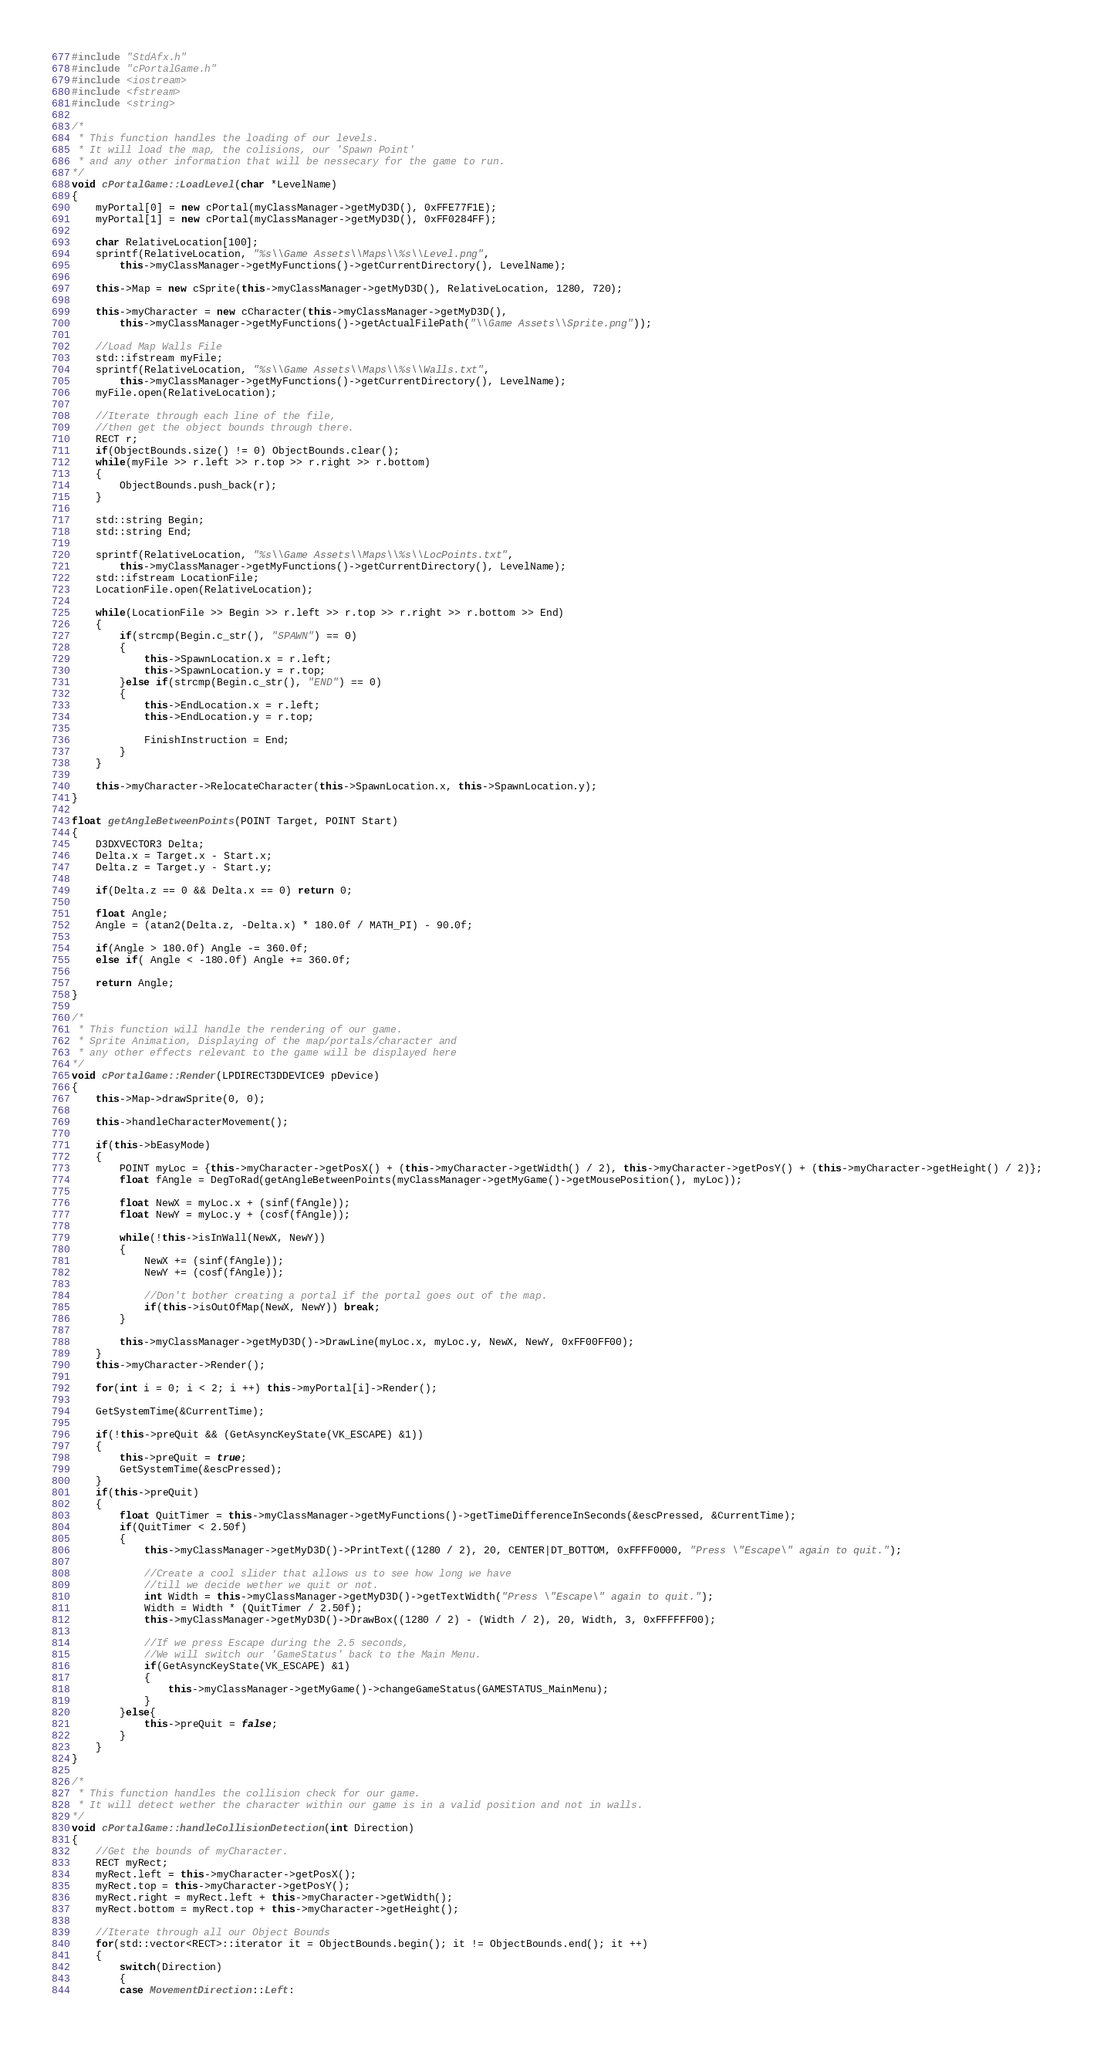<code> <loc_0><loc_0><loc_500><loc_500><_C++_>#include "StdAfx.h"
#include "cPortalGame.h"
#include <iostream>
#include <fstream>
#include <string>

/*
 * This function handles the loading of our levels.
 * It will load the map, the colisions, our 'Spawn Point'
 * and any other information that will be nessecary for the game to run.
*/
void cPortalGame::LoadLevel(char *LevelName)
{
	myPortal[0] = new cPortal(myClassManager->getMyD3D(), 0xFFE77F1E);
	myPortal[1] = new cPortal(myClassManager->getMyD3D(), 0xFF0284FF);

	char RelativeLocation[100];
	sprintf(RelativeLocation, "%s\\Game Assets\\Maps\\%s\\Level.png", 
		this->myClassManager->getMyFunctions()->getCurrentDirectory(), LevelName);

	this->Map = new cSprite(this->myClassManager->getMyD3D(), RelativeLocation, 1280, 720);

	this->myCharacter = new cCharacter(this->myClassManager->getMyD3D(),
		this->myClassManager->getMyFunctions()->getActualFilePath("\\Game Assets\\Sprite.png"));

	//Load Map Walls File
	std::ifstream myFile;
	sprintf(RelativeLocation, "%s\\Game Assets\\Maps\\%s\\Walls.txt", 
		this->myClassManager->getMyFunctions()->getCurrentDirectory(), LevelName);
	myFile.open(RelativeLocation);

	//Iterate through each line of the file,
	//then get the object bounds through there.
	RECT r;
	if(ObjectBounds.size() != 0) ObjectBounds.clear();
	while(myFile >> r.left >> r.top >> r.right >> r.bottom)
	{
		ObjectBounds.push_back(r);
	}

	std::string Begin;
	std::string End;

	sprintf(RelativeLocation, "%s\\Game Assets\\Maps\\%s\\LocPoints.txt", 
		this->myClassManager->getMyFunctions()->getCurrentDirectory(), LevelName);
	std::ifstream LocationFile;
	LocationFile.open(RelativeLocation);

	while(LocationFile >> Begin >> r.left >> r.top >> r.right >> r.bottom >> End)
	{
		if(strcmp(Begin.c_str(), "SPAWN") == 0) 
		{	
			this->SpawnLocation.x = r.left;
			this->SpawnLocation.y = r.top;
		}else if(strcmp(Begin.c_str(), "END") == 0)
		{
			this->EndLocation.x = r.left;
			this->EndLocation.y = r.top;

			FinishInstruction = End;
		}
	}
	
	this->myCharacter->RelocateCharacter(this->SpawnLocation.x, this->SpawnLocation.y);
}

float getAngleBetweenPoints(POINT Target, POINT Start)
{
	D3DXVECTOR3 Delta;
	Delta.x = Target.x - Start.x;
	Delta.z = Target.y - Start.y;

	if(Delta.z == 0 && Delta.x == 0) return 0;

	float Angle;
	Angle = (atan2(Delta.z, -Delta.x) * 180.0f / MATH_PI) - 90.0f;

	if(Angle > 180.0f) Angle -= 360.0f;
	else if( Angle < -180.0f) Angle += 360.0f;

	return Angle;
}

/*
 * This function will handle the rendering of our game.
 * Sprite Animation, Displaying of the map/portals/character and
 * any other effects relevant to the game will be displayed here
*/
void cPortalGame::Render(LPDIRECT3DDEVICE9 pDevice)
{
	this->Map->drawSprite(0, 0);

	this->handleCharacterMovement();

	if(this->bEasyMode)
	{
		POINT myLoc = {this->myCharacter->getPosX() + (this->myCharacter->getWidth() / 2), this->myCharacter->getPosY() + (this->myCharacter->getHeight() / 2)};
		float fAngle = DegToRad(getAngleBetweenPoints(myClassManager->getMyGame()->getMousePosition(), myLoc));

		float NewX = myLoc.x + (sinf(fAngle));
		float NewY = myLoc.y + (cosf(fAngle));

		while(!this->isInWall(NewX, NewY))
		{
			NewX += (sinf(fAngle));
			NewY += (cosf(fAngle));

			//Don't bother creating a portal if the portal goes out of the map.
			if(this->isOutOfMap(NewX, NewY)) break;
		}

		this->myClassManager->getMyD3D()->DrawLine(myLoc.x, myLoc.y, NewX, NewY, 0xFF00FF00);
	}
	this->myCharacter->Render();

	for(int i = 0; i < 2; i ++) this->myPortal[i]->Render();

	GetSystemTime(&CurrentTime);

	if(!this->preQuit && (GetAsyncKeyState(VK_ESCAPE) &1))
	{
		this->preQuit = true;
		GetSystemTime(&escPressed);
	}
	if(this->preQuit)
	{
		float QuitTimer = this->myClassManager->getMyFunctions()->getTimeDifferenceInSeconds(&escPressed, &CurrentTime);
		if(QuitTimer < 2.50f)
		{
			this->myClassManager->getMyD3D()->PrintText((1280 / 2), 20, CENTER|DT_BOTTOM, 0xFFFF0000, "Press \"Escape\" again to quit.");

			//Create a cool slider that allows us to see how long we have
			//till we decide wether we quit or not.
			int Width = this->myClassManager->getMyD3D()->getTextWidth("Press \"Escape\" again to quit.");
			Width = Width * (QuitTimer / 2.50f);
			this->myClassManager->getMyD3D()->DrawBox((1280 / 2) - (Width / 2), 20, Width, 3, 0xFFFFFF00);

			//If we press Escape during the 2.5 seconds,
			//We will switch our 'GameStatus' back to the Main Menu.
			if(GetAsyncKeyState(VK_ESCAPE) &1)
			{
				this->myClassManager->getMyGame()->changeGameStatus(GAMESTATUS_MainMenu);
			}
		}else{
			this->preQuit = false;
		}
	}
}

/*
 * This function handles the collision check for our game.
 * It will detect wether the character within our game is in a valid position and not in walls.
*/
void cPortalGame::handleCollisionDetection(int Direction)
{
	//Get the bounds of myCharacter.
	RECT myRect;
	myRect.left = this->myCharacter->getPosX();
	myRect.top = this->myCharacter->getPosY();
	myRect.right = myRect.left + this->myCharacter->getWidth();
	myRect.bottom = myRect.top + this->myCharacter->getHeight();

	//Iterate through all our Object Bounds
	for(std::vector<RECT>::iterator it = ObjectBounds.begin(); it != ObjectBounds.end(); it ++)
	{		
		switch(Direction)
		{
		case MovementDirection::Left:</code> 